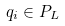Convert formula to latex. <formula><loc_0><loc_0><loc_500><loc_500>q _ { i } \in P _ { L }</formula> 